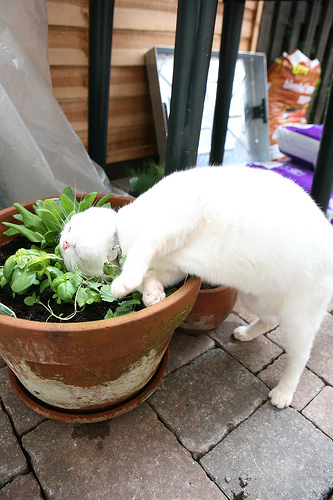What is the animal that the collar is on called? The animal that the collar is on is called a cat. 